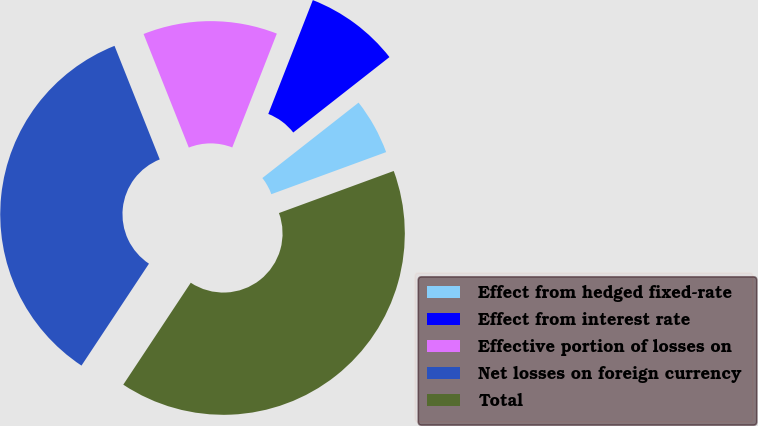Convert chart. <chart><loc_0><loc_0><loc_500><loc_500><pie_chart><fcel>Effect from hedged fixed-rate<fcel>Effect from interest rate<fcel>Effective portion of losses on<fcel>Net losses on foreign currency<fcel>Total<nl><fcel>4.99%<fcel>8.48%<fcel>11.97%<fcel>34.66%<fcel>39.9%<nl></chart> 